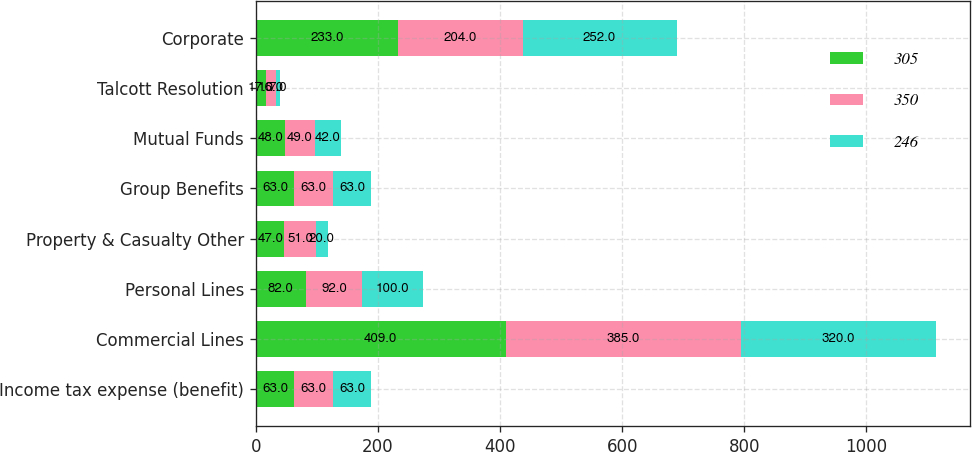Convert chart to OTSL. <chart><loc_0><loc_0><loc_500><loc_500><stacked_bar_chart><ecel><fcel>Income tax expense (benefit)<fcel>Commercial Lines<fcel>Personal Lines<fcel>Property & Casualty Other<fcel>Group Benefits<fcel>Mutual Funds<fcel>Talcott Resolution<fcel>Corporate<nl><fcel>305<fcel>63<fcel>409<fcel>82<fcel>47<fcel>63<fcel>48<fcel>17<fcel>233<nl><fcel>350<fcel>63<fcel>385<fcel>92<fcel>51<fcel>63<fcel>49<fcel>16<fcel>204<nl><fcel>246<fcel>63<fcel>320<fcel>100<fcel>20<fcel>63<fcel>42<fcel>7<fcel>252<nl></chart> 